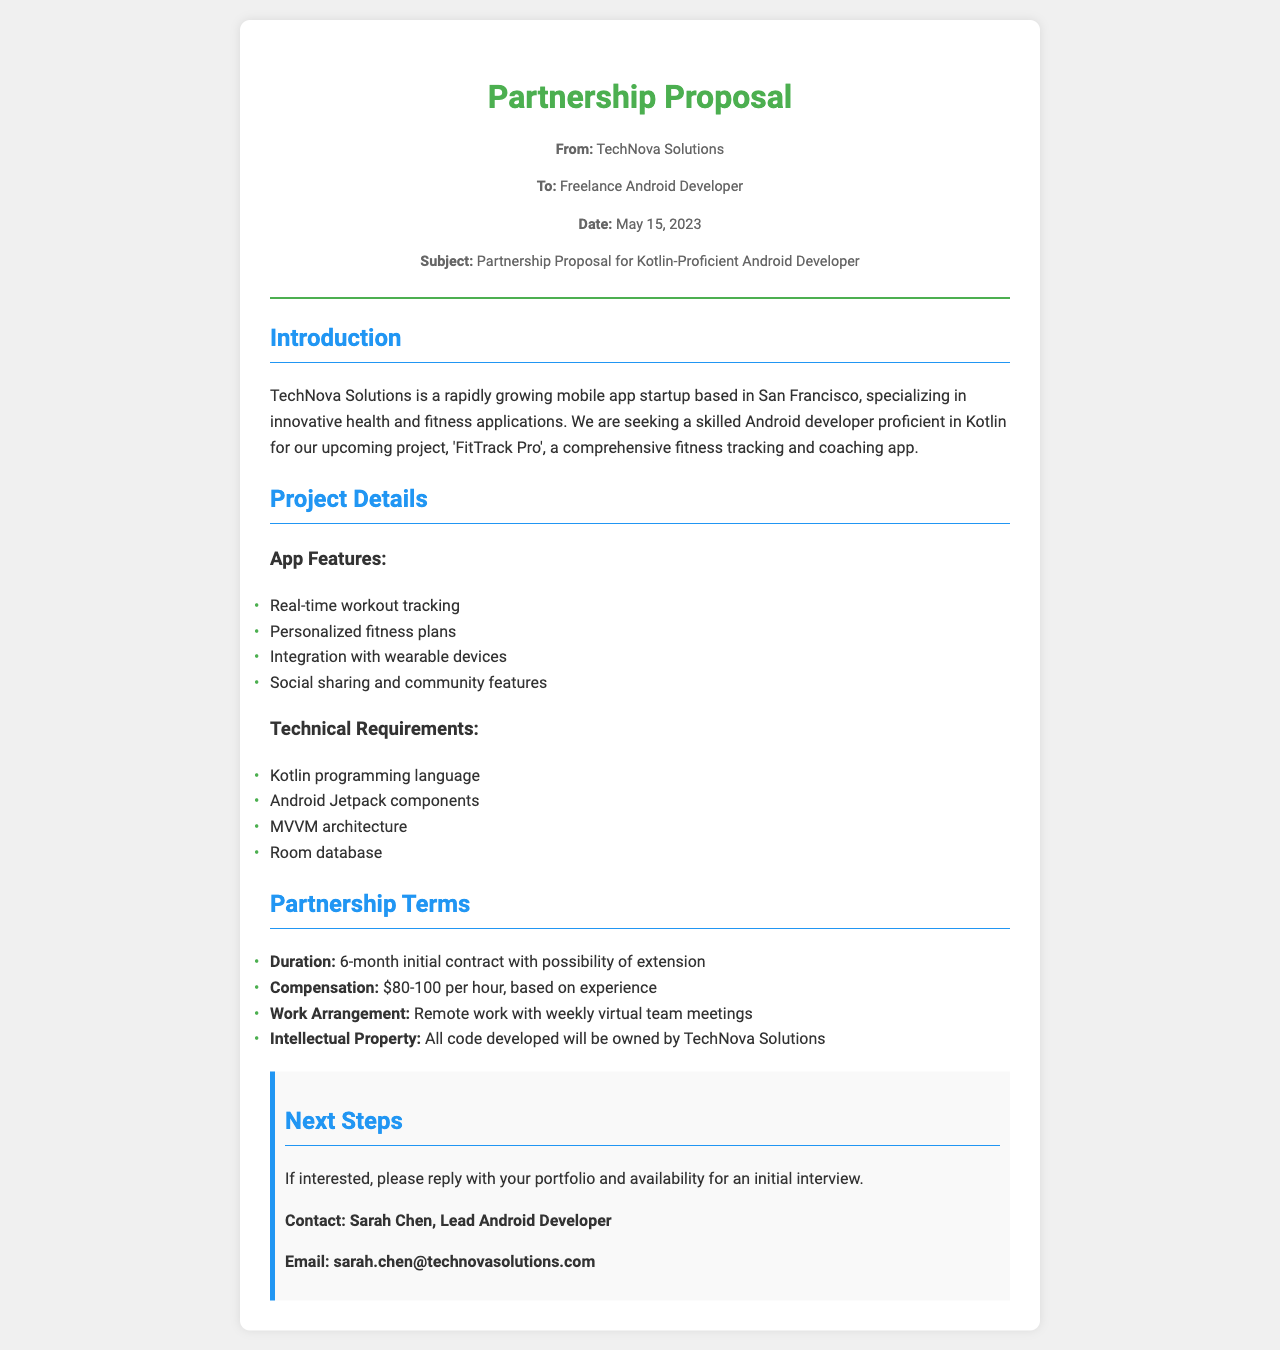What is the name of the app being developed? The app being developed is mentioned as 'FitTrack Pro' in the Project Details section.
Answer: FitTrack Pro Who is the sender of the proposal? The sender of the proposal is listed as TechNova Solutions at the top of the document.
Answer: TechNova Solutions What is the duration of the initial contract? The document specifies a 6-month initial contract in the Partnership Terms section.
Answer: 6-month What is the compensation range offered for the developer? The compensation range is provided as $80-100 per hour based on experience in the document.
Answer: $80-100 per hour What programming language is required for the project? Kotlin is identified as the required programming language in the Technical Requirements section.
Answer: Kotlin What will happen to the intellectual property developed? The document states that all code developed will be owned by TechNova Solutions in the Partnership Terms.
Answer: Owned by TechNova Solutions What is the email contact for the proposal? The contact email for Sarah Chen is mentioned in the Next Steps section.
Answer: sarah.chen@technovasolutions.com What is the work arrangement for the developer? The document states that the work arrangement is remote work with weekly virtual team meetings.
Answer: Remote work How many features are listed for the app? There are four features listed under the App Features section in the document.
Answer: Four 